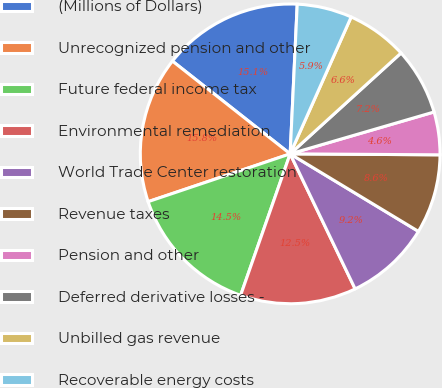<chart> <loc_0><loc_0><loc_500><loc_500><pie_chart><fcel>(Millions of Dollars)<fcel>Unrecognized pension and other<fcel>Future federal income tax<fcel>Environmental remediation<fcel>World Trade Center restoration<fcel>Revenue taxes<fcel>Pension and other<fcel>Deferred derivative losses -<fcel>Unbilled gas revenue<fcel>Recoverable energy costs<nl><fcel>15.13%<fcel>15.79%<fcel>14.47%<fcel>12.5%<fcel>9.21%<fcel>8.55%<fcel>4.61%<fcel>7.24%<fcel>6.58%<fcel>5.92%<nl></chart> 